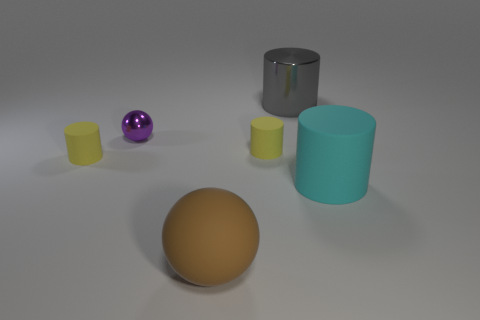What is the shape of the cyan matte object?
Your answer should be very brief. Cylinder. What number of large things have the same material as the small purple ball?
Your response must be concise. 1. The large cylinder that is the same material as the big ball is what color?
Offer a terse response. Cyan. Does the metallic ball have the same size as the matte cylinder that is right of the metal cylinder?
Offer a terse response. No. What material is the small yellow thing behind the yellow cylinder on the left side of the yellow object that is right of the brown sphere made of?
Keep it short and to the point. Rubber. What number of objects are tiny metallic spheres or tiny yellow matte cubes?
Your answer should be compact. 1. Is the color of the big cylinder that is in front of the large gray object the same as the sphere that is to the right of the tiny purple metallic sphere?
Provide a short and direct response. No. There is a cyan object that is the same size as the gray metal cylinder; what shape is it?
Provide a succinct answer. Cylinder. How many objects are cylinders behind the small purple ball or cylinders in front of the large gray object?
Your answer should be very brief. 4. Is the number of gray objects less than the number of large matte things?
Make the answer very short. Yes. 